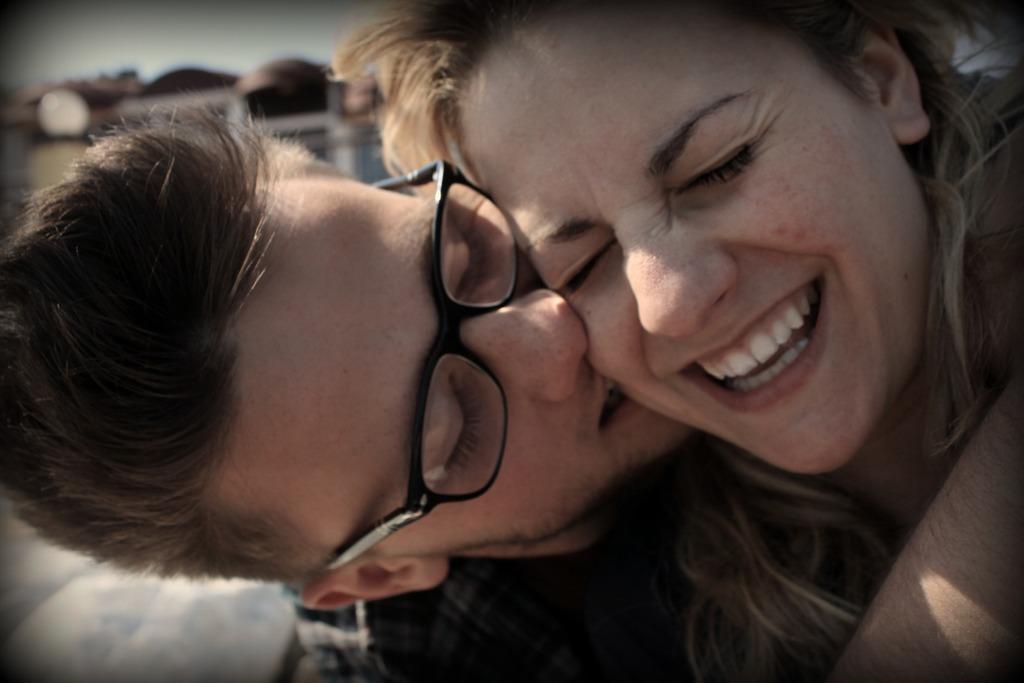Can you describe this image briefly? In this image, we can see a man and a lady and the man is wearing glasses and the background is blurry. 